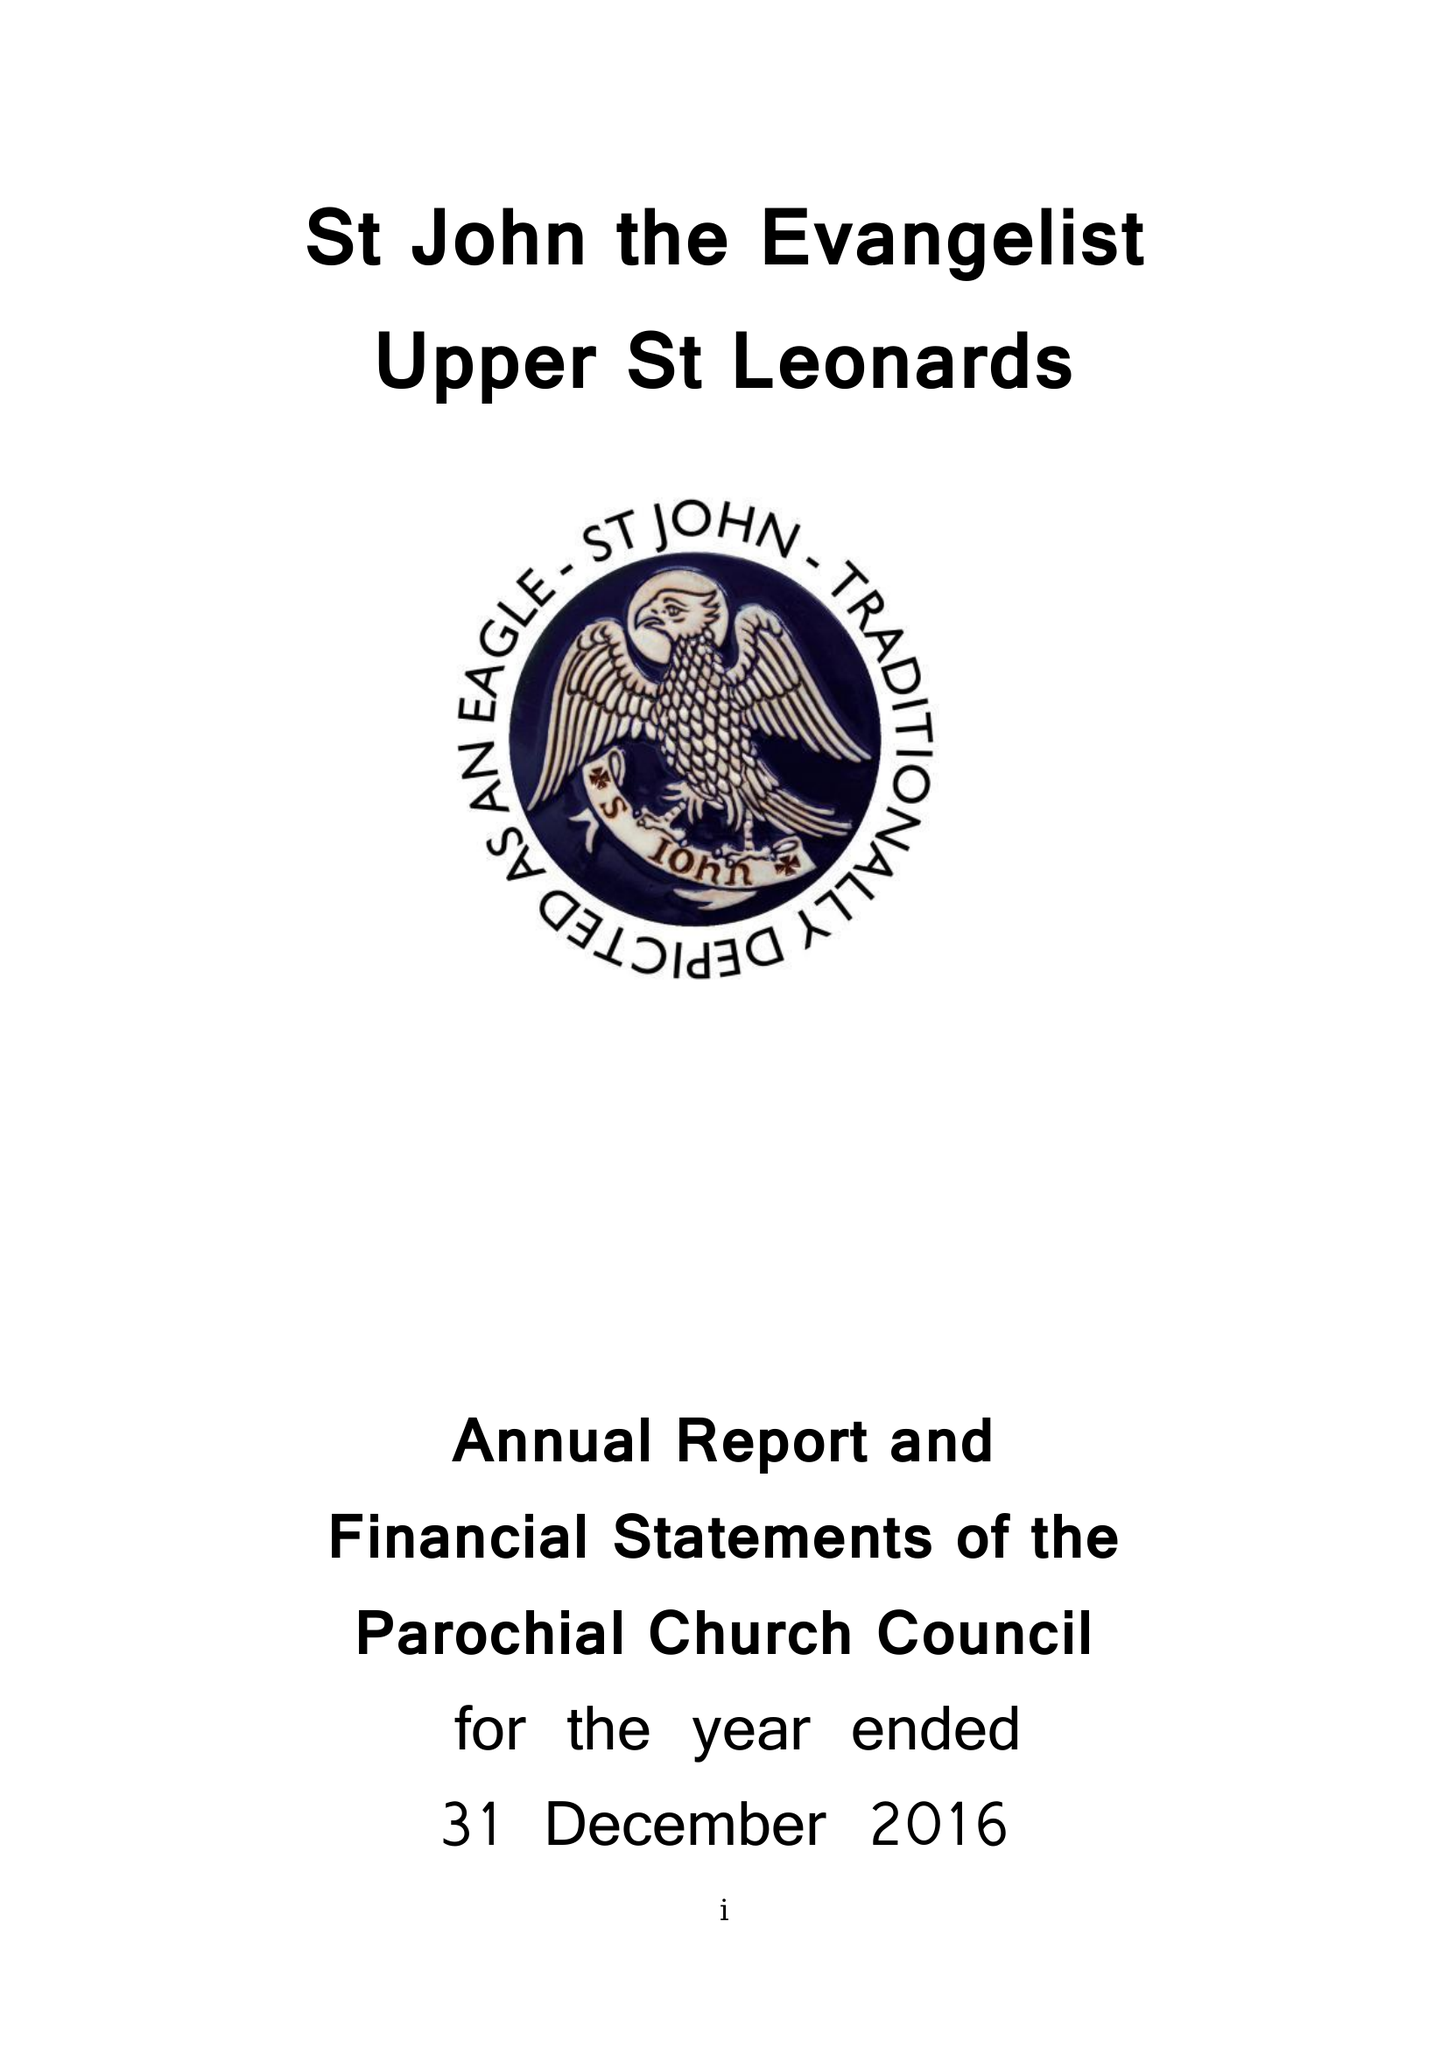What is the value for the charity_name?
Answer the question using a single word or phrase. The Parochial Church Council Of The Ecclesiastical Parish Of St John The Evangelist Upper St Leonards On Sea 